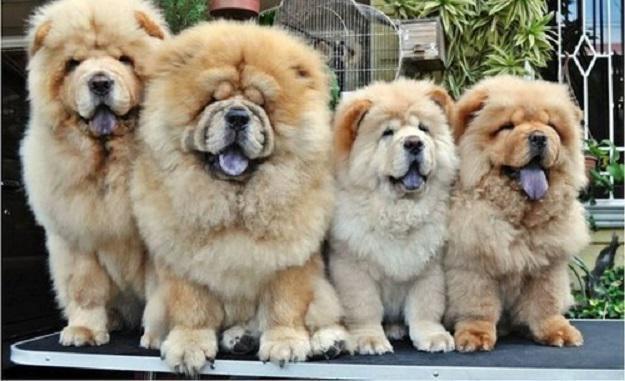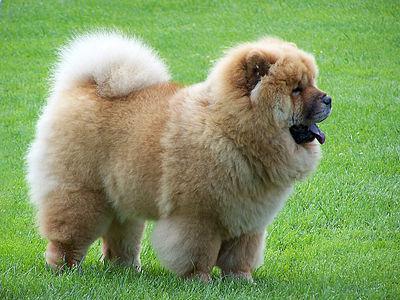The first image is the image on the left, the second image is the image on the right. Given the left and right images, does the statement "There are two dogs shown in total." hold true? Answer yes or no. No. The first image is the image on the left, the second image is the image on the right. Analyze the images presented: Is the assertion "At least three dogs are shown, with only one in a grassy area." valid? Answer yes or no. Yes. 